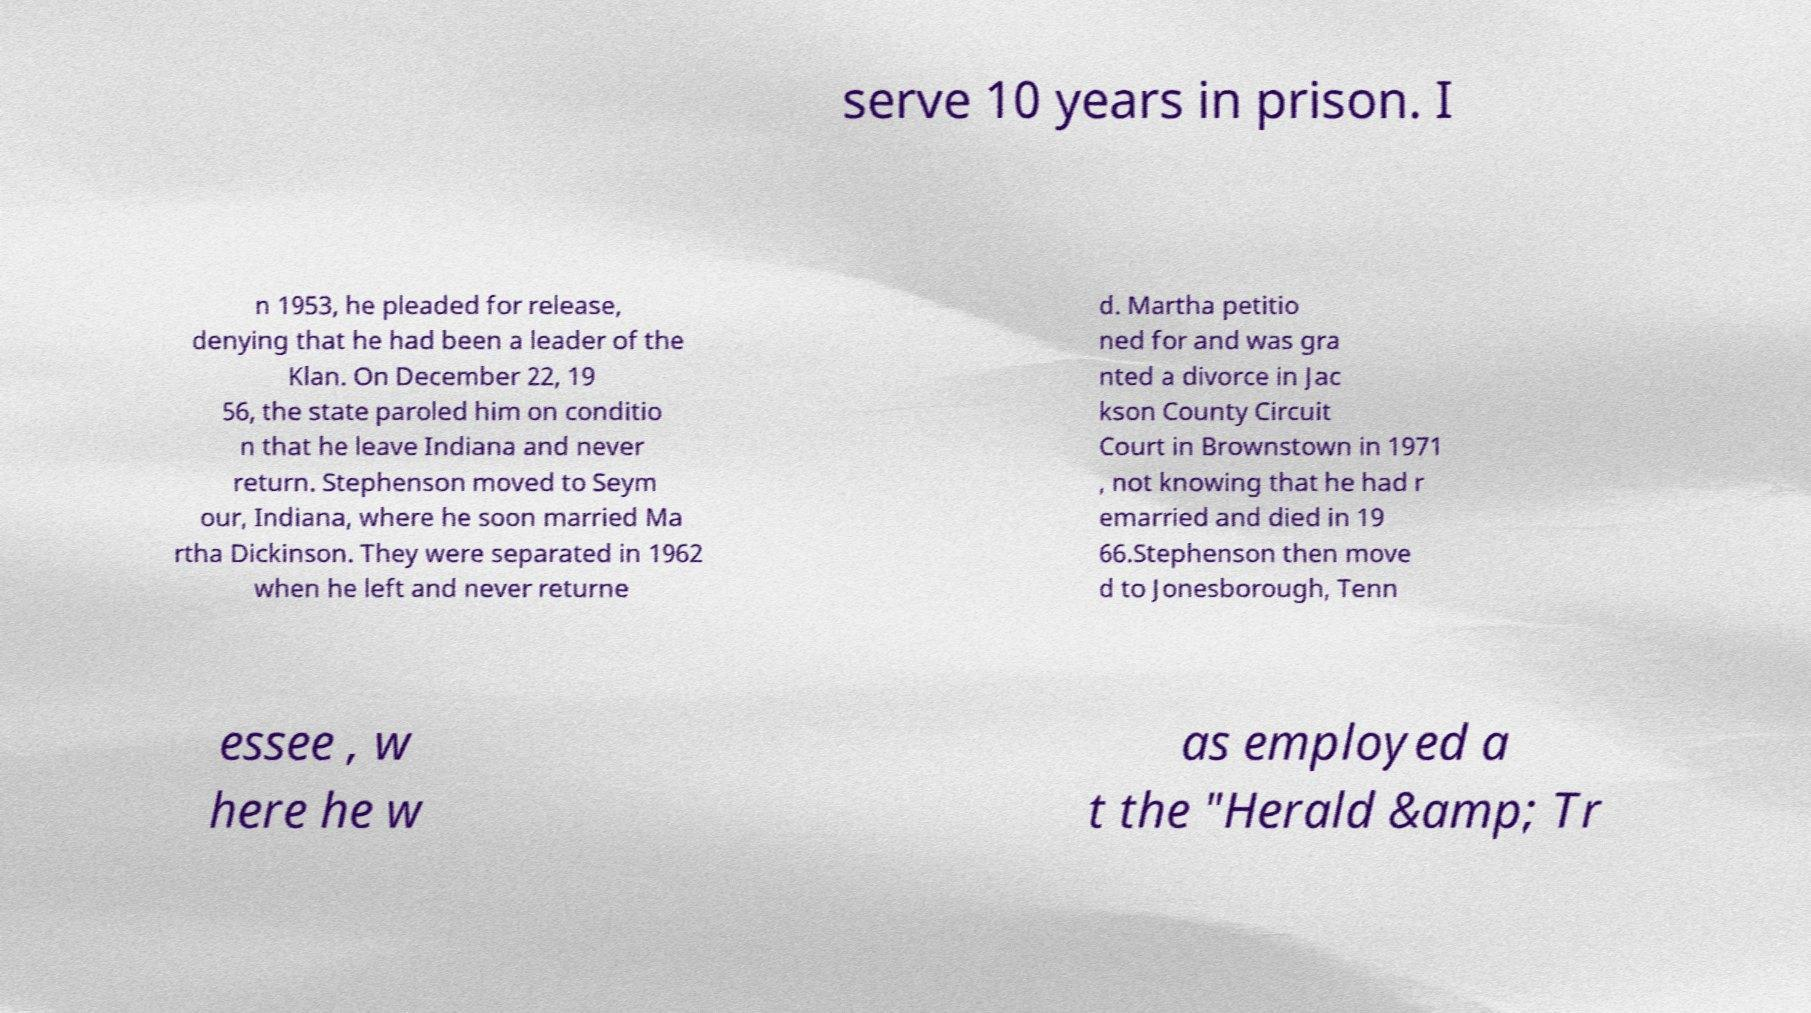There's text embedded in this image that I need extracted. Can you transcribe it verbatim? serve 10 years in prison. I n 1953, he pleaded for release, denying that he had been a leader of the Klan. On December 22, 19 56, the state paroled him on conditio n that he leave Indiana and never return. Stephenson moved to Seym our, Indiana, where he soon married Ma rtha Dickinson. They were separated in 1962 when he left and never returne d. Martha petitio ned for and was gra nted a divorce in Jac kson County Circuit Court in Brownstown in 1971 , not knowing that he had r emarried and died in 19 66.Stephenson then move d to Jonesborough, Tenn essee , w here he w as employed a t the "Herald &amp; Tr 